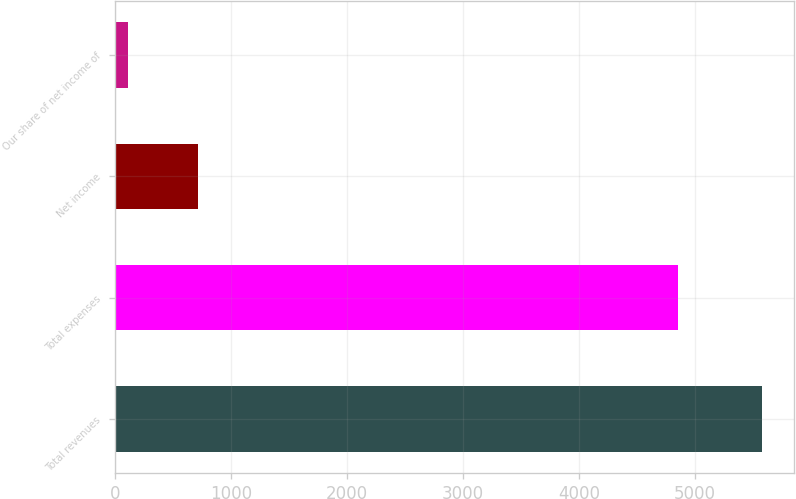<chart> <loc_0><loc_0><loc_500><loc_500><bar_chart><fcel>Total revenues<fcel>Total expenses<fcel>Net income<fcel>Our share of net income of<nl><fcel>5574.6<fcel>4849.8<fcel>719.3<fcel>116.5<nl></chart> 